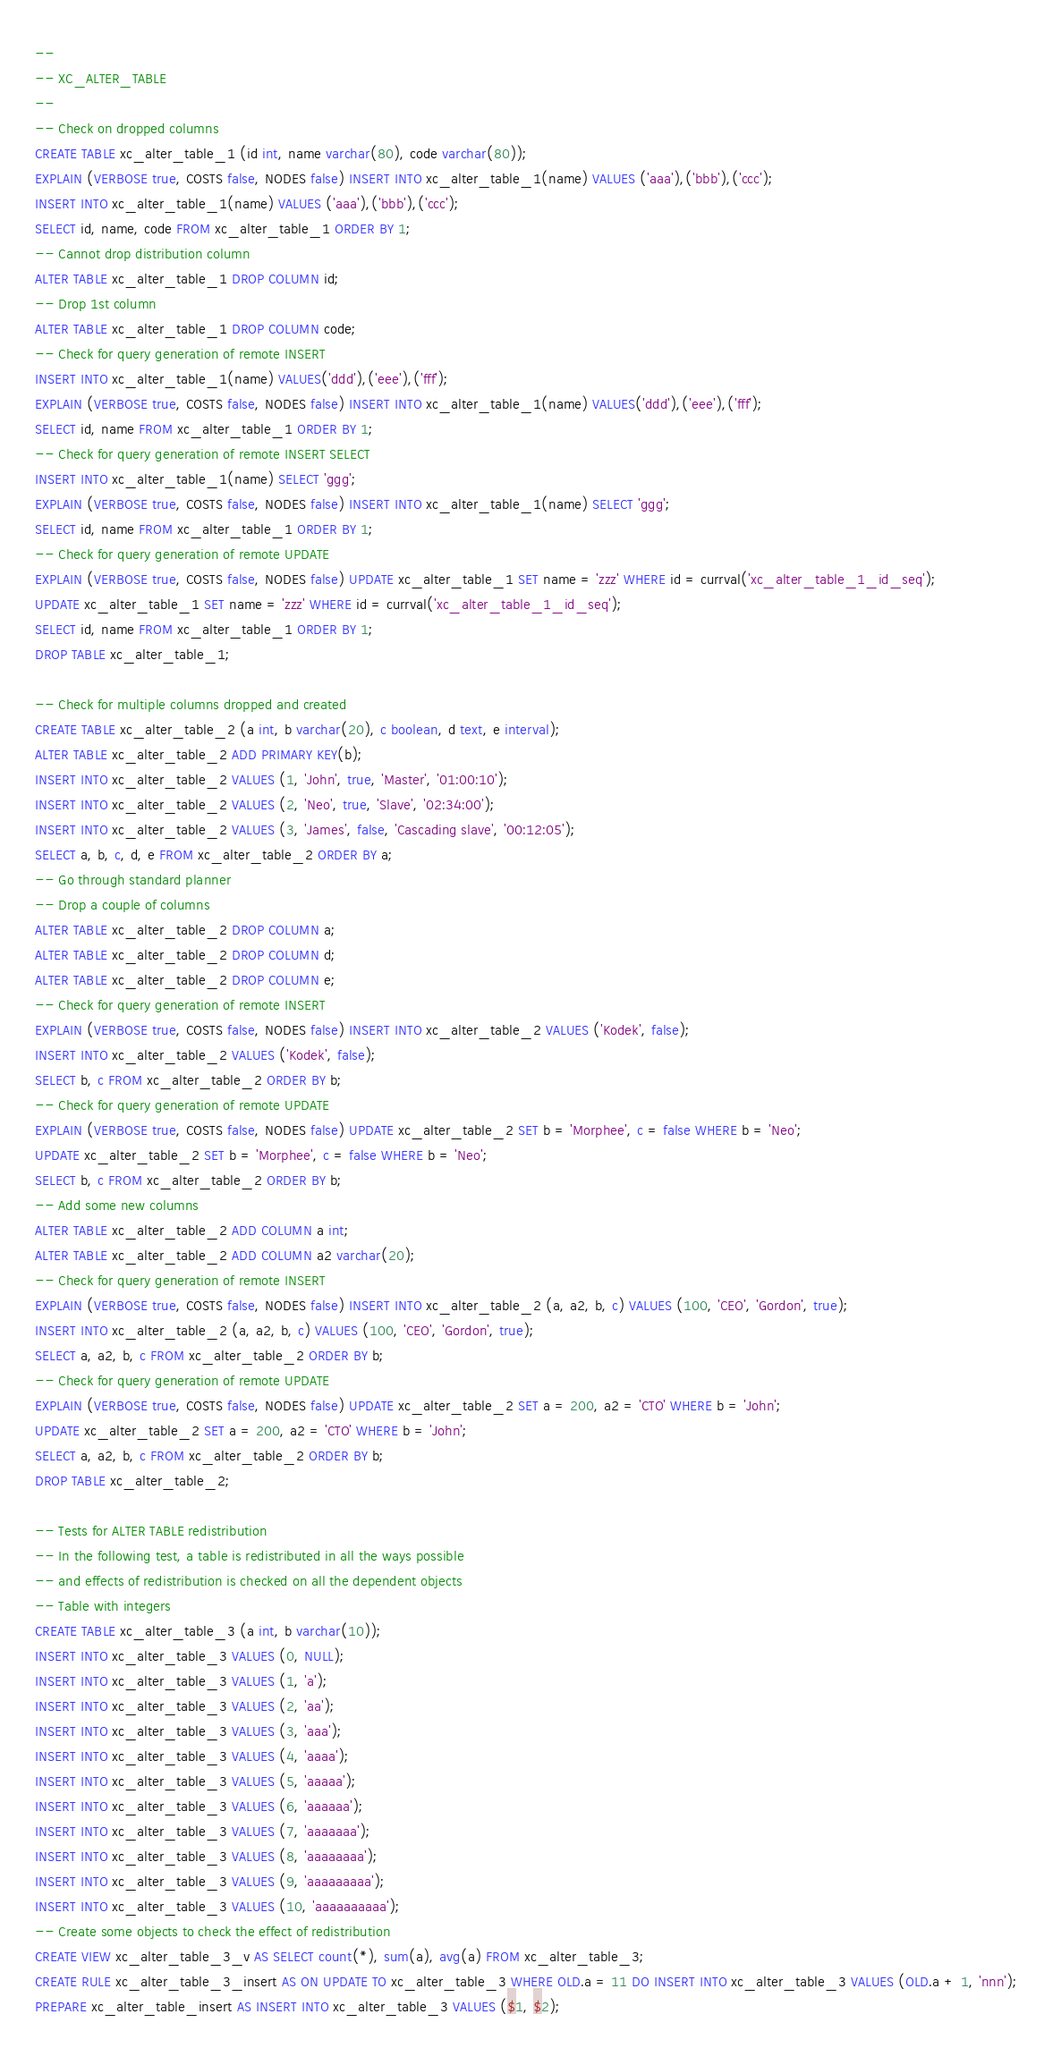<code> <loc_0><loc_0><loc_500><loc_500><_SQL_>--
-- XC_ALTER_TABLE
--
-- Check on dropped columns
CREATE TABLE xc_alter_table_1 (id int, name varchar(80), code varchar(80));
EXPLAIN (VERBOSE true, COSTS false, NODES false) INSERT INTO xc_alter_table_1(name) VALUES ('aaa'),('bbb'),('ccc');
INSERT INTO xc_alter_table_1(name) VALUES ('aaa'),('bbb'),('ccc');
SELECT id, name, code FROM xc_alter_table_1 ORDER BY 1;
-- Cannot drop distribution column
ALTER TABLE xc_alter_table_1 DROP COLUMN id;
-- Drop 1st column
ALTER TABLE xc_alter_table_1 DROP COLUMN code;
-- Check for query generation of remote INSERT
INSERT INTO xc_alter_table_1(name) VALUES('ddd'),('eee'),('fff');
EXPLAIN (VERBOSE true, COSTS false, NODES false) INSERT INTO xc_alter_table_1(name) VALUES('ddd'),('eee'),('fff');
SELECT id, name FROM xc_alter_table_1 ORDER BY 1;
-- Check for query generation of remote INSERT SELECT
INSERT INTO xc_alter_table_1(name) SELECT 'ggg';
EXPLAIN (VERBOSE true, COSTS false, NODES false) INSERT INTO xc_alter_table_1(name) SELECT 'ggg';
SELECT id, name FROM xc_alter_table_1 ORDER BY 1;
-- Check for query generation of remote UPDATE
EXPLAIN (VERBOSE true, COSTS false, NODES false) UPDATE xc_alter_table_1 SET name = 'zzz' WHERE id = currval('xc_alter_table_1_id_seq');
UPDATE xc_alter_table_1 SET name = 'zzz' WHERE id = currval('xc_alter_table_1_id_seq');
SELECT id, name FROM xc_alter_table_1 ORDER BY 1;
DROP TABLE xc_alter_table_1;

-- Check for multiple columns dropped and created
CREATE TABLE xc_alter_table_2 (a int, b varchar(20), c boolean, d text, e interval);
ALTER TABLE xc_alter_table_2 ADD PRIMARY KEY(b);
INSERT INTO xc_alter_table_2 VALUES (1, 'John', true, 'Master', '01:00:10');
INSERT INTO xc_alter_table_2 VALUES (2, 'Neo', true, 'Slave', '02:34:00');
INSERT INTO xc_alter_table_2 VALUES (3, 'James', false, 'Cascading slave', '00:12:05');
SELECT a, b, c, d, e FROM xc_alter_table_2 ORDER BY a;
-- Go through standard planner
-- Drop a couple of columns
ALTER TABLE xc_alter_table_2 DROP COLUMN a;
ALTER TABLE xc_alter_table_2 DROP COLUMN d;
ALTER TABLE xc_alter_table_2 DROP COLUMN e;
-- Check for query generation of remote INSERT
EXPLAIN (VERBOSE true, COSTS false, NODES false) INSERT INTO xc_alter_table_2 VALUES ('Kodek', false);
INSERT INTO xc_alter_table_2 VALUES ('Kodek', false);
SELECT b, c FROM xc_alter_table_2 ORDER BY b;
-- Check for query generation of remote UPDATE
EXPLAIN (VERBOSE true, COSTS false, NODES false) UPDATE xc_alter_table_2 SET b = 'Morphee', c = false WHERE b = 'Neo';
UPDATE xc_alter_table_2 SET b = 'Morphee', c = false WHERE b = 'Neo';
SELECT b, c FROM xc_alter_table_2 ORDER BY b;
-- Add some new columns
ALTER TABLE xc_alter_table_2 ADD COLUMN a int;
ALTER TABLE xc_alter_table_2 ADD COLUMN a2 varchar(20);
-- Check for query generation of remote INSERT
EXPLAIN (VERBOSE true, COSTS false, NODES false) INSERT INTO xc_alter_table_2 (a, a2, b, c) VALUES (100, 'CEO', 'Gordon', true);
INSERT INTO xc_alter_table_2 (a, a2, b, c) VALUES (100, 'CEO', 'Gordon', true);
SELECT a, a2, b, c FROM xc_alter_table_2 ORDER BY b;
-- Check for query generation of remote UPDATE
EXPLAIN (VERBOSE true, COSTS false, NODES false) UPDATE xc_alter_table_2 SET a = 200, a2 = 'CTO' WHERE b = 'John';
UPDATE xc_alter_table_2 SET a = 200, a2 = 'CTO' WHERE b = 'John';
SELECT a, a2, b, c FROM xc_alter_table_2 ORDER BY b;
DROP TABLE xc_alter_table_2;

-- Tests for ALTER TABLE redistribution
-- In the following test, a table is redistributed in all the ways possible
-- and effects of redistribution is checked on all the dependent objects
-- Table with integers
CREATE TABLE xc_alter_table_3 (a int, b varchar(10));
INSERT INTO xc_alter_table_3 VALUES (0, NULL);
INSERT INTO xc_alter_table_3 VALUES (1, 'a');
INSERT INTO xc_alter_table_3 VALUES (2, 'aa');
INSERT INTO xc_alter_table_3 VALUES (3, 'aaa');
INSERT INTO xc_alter_table_3 VALUES (4, 'aaaa');
INSERT INTO xc_alter_table_3 VALUES (5, 'aaaaa');
INSERT INTO xc_alter_table_3 VALUES (6, 'aaaaaa');
INSERT INTO xc_alter_table_3 VALUES (7, 'aaaaaaa');
INSERT INTO xc_alter_table_3 VALUES (8, 'aaaaaaaa');
INSERT INTO xc_alter_table_3 VALUES (9, 'aaaaaaaaa');
INSERT INTO xc_alter_table_3 VALUES (10, 'aaaaaaaaaa');
-- Create some objects to check the effect of redistribution
CREATE VIEW xc_alter_table_3_v AS SELECT count(*), sum(a), avg(a) FROM xc_alter_table_3;
CREATE RULE xc_alter_table_3_insert AS ON UPDATE TO xc_alter_table_3 WHERE OLD.a = 11 DO INSERT INTO xc_alter_table_3 VALUES (OLD.a + 1, 'nnn');
PREPARE xc_alter_table_insert AS INSERT INTO xc_alter_table_3 VALUES ($1, $2);</code> 